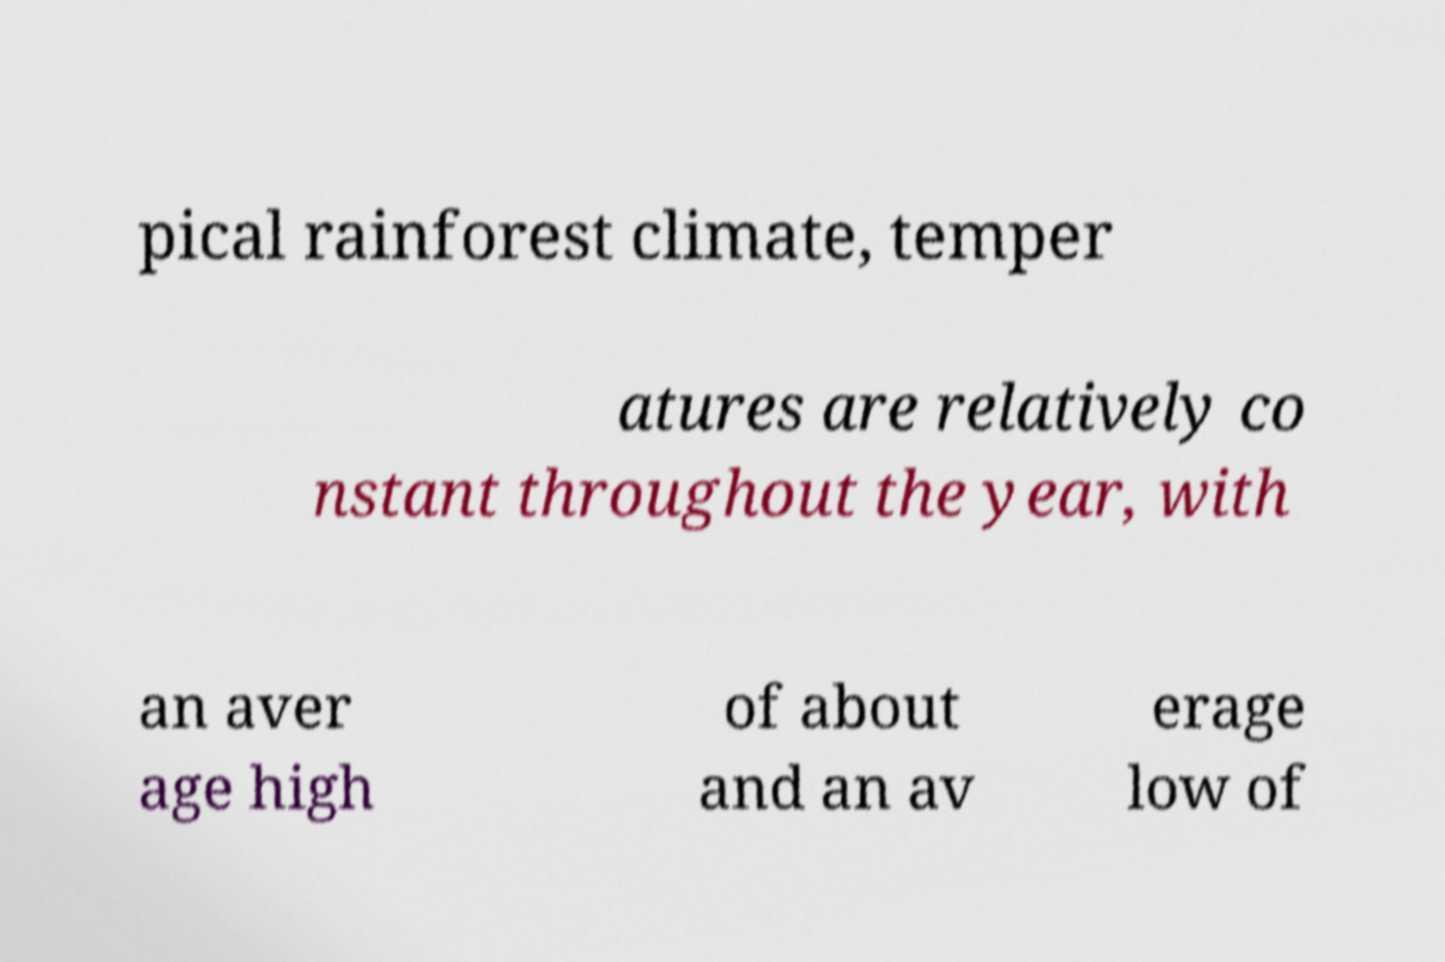Could you extract and type out the text from this image? pical rainforest climate, temper atures are relatively co nstant throughout the year, with an aver age high of about and an av erage low of 